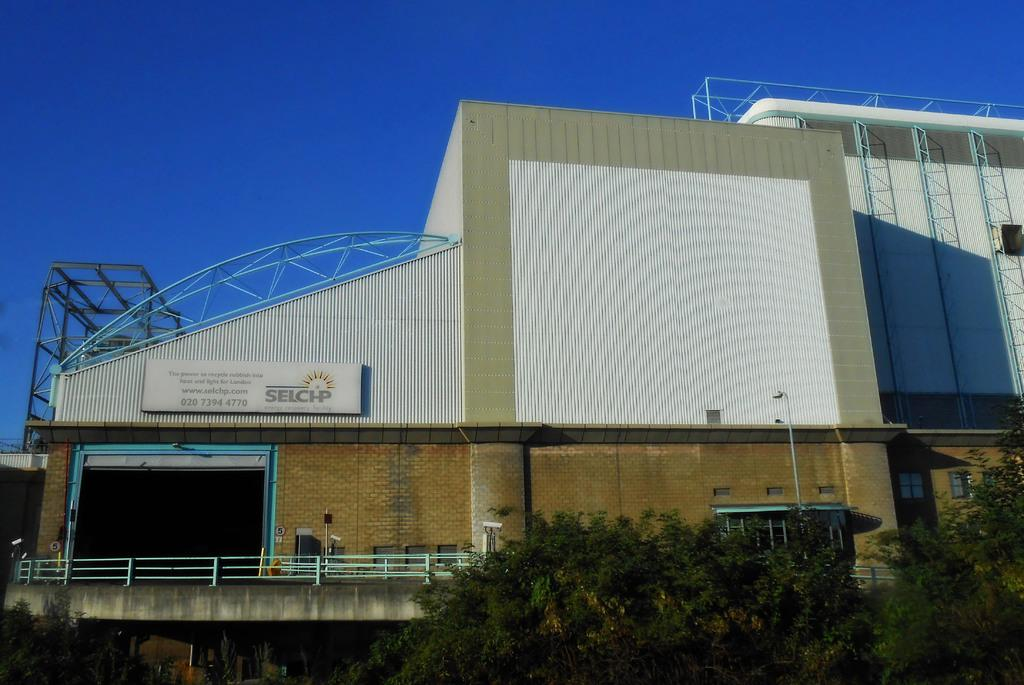What type of structure is depicted in the image? There is a building in the image, which resembles a factory. What can be seen at the bottom of the image? There are trees at the bottom of the image. What is visible at the top of the image? The sky is visible at the top of the image. What type of ladders are present on the right side of the image? There are small ladders made of iron on the right side of the image. Can you see the hand of the person holding the ball in the image? There is no person holding a ball present in the image. 